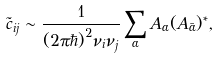<formula> <loc_0><loc_0><loc_500><loc_500>\tilde { c } _ { i j } \sim \frac { 1 } { ( 2 \pi \hbar { ) } ^ { 2 } \nu _ { i } \nu _ { j } } \sum _ { \alpha } A _ { \alpha } ( A _ { \bar { \alpha } } ) ^ { * } ,</formula> 